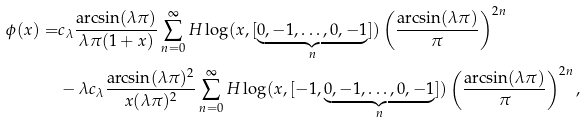<formula> <loc_0><loc_0><loc_500><loc_500>\phi ( x ) = & c _ { \lambda } \frac { \arcsin ( \lambda \pi ) } { \lambda \pi ( 1 + x ) } \sum _ { n = 0 } ^ { \infty } H \log ( x , [ \underbrace { 0 , - 1 , \dots , 0 , - 1 } _ { n } ] ) \left ( \frac { \arcsin ( \lambda \pi ) } { \pi } \right ) ^ { 2 n } \\ & - \lambda c _ { \lambda } \frac { \arcsin ( \lambda \pi ) ^ { 2 } } { x ( \lambda \pi ) ^ { 2 } } \sum _ { n = 0 } ^ { \infty } H \log ( x , [ - 1 , \underbrace { 0 , - 1 , \dots , 0 , - 1 } _ { n } ] ) \left ( \frac { \arcsin ( \lambda \pi ) } { \pi } \right ) ^ { 2 n } ,</formula> 